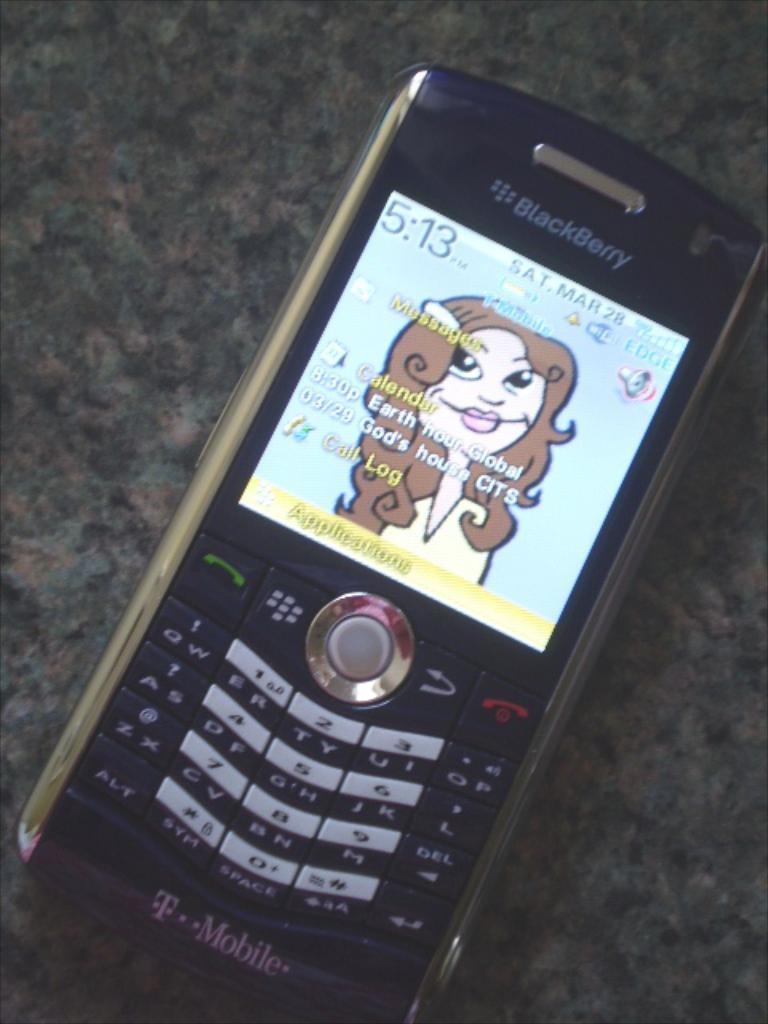What is the brand of the phone?
Provide a short and direct response. Blackberry. 